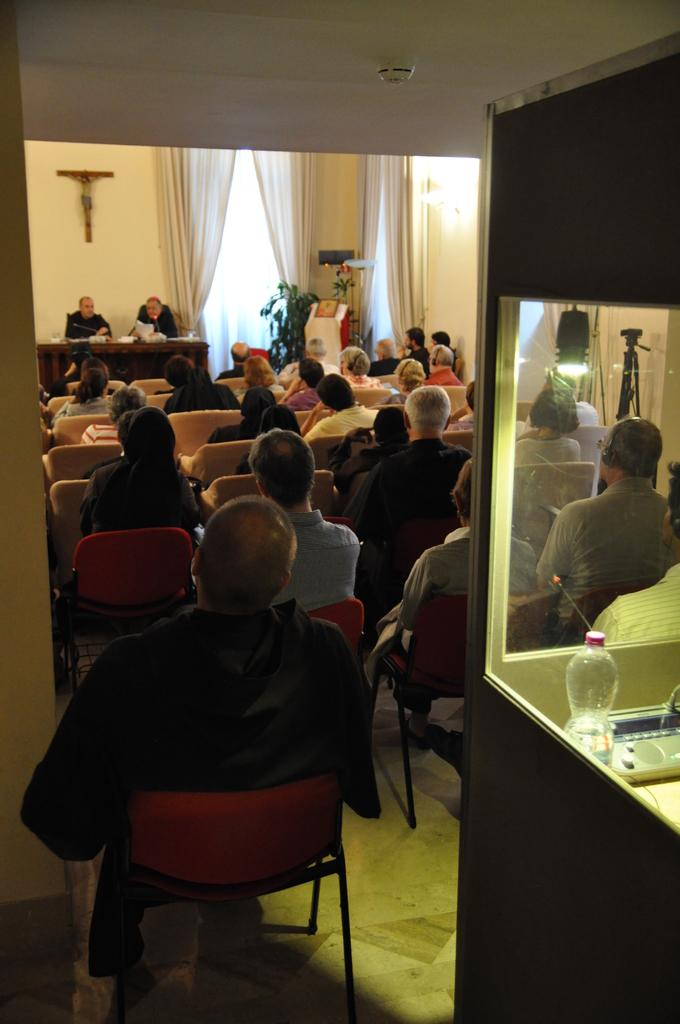How many people are in the image? There is a group of people in the image. What are the people doing in the image? The people are sitting on chairs. What is present in the image besides the people? There is a table in the image. What can be seen on the table? There is a bottle on the table, and there are other objects on the table as well. What color is the rose on the table in the image? There is no rose present on the table in the image. How many shades of gray can be seen on the faucet in the image? There is no faucet present in the image. 